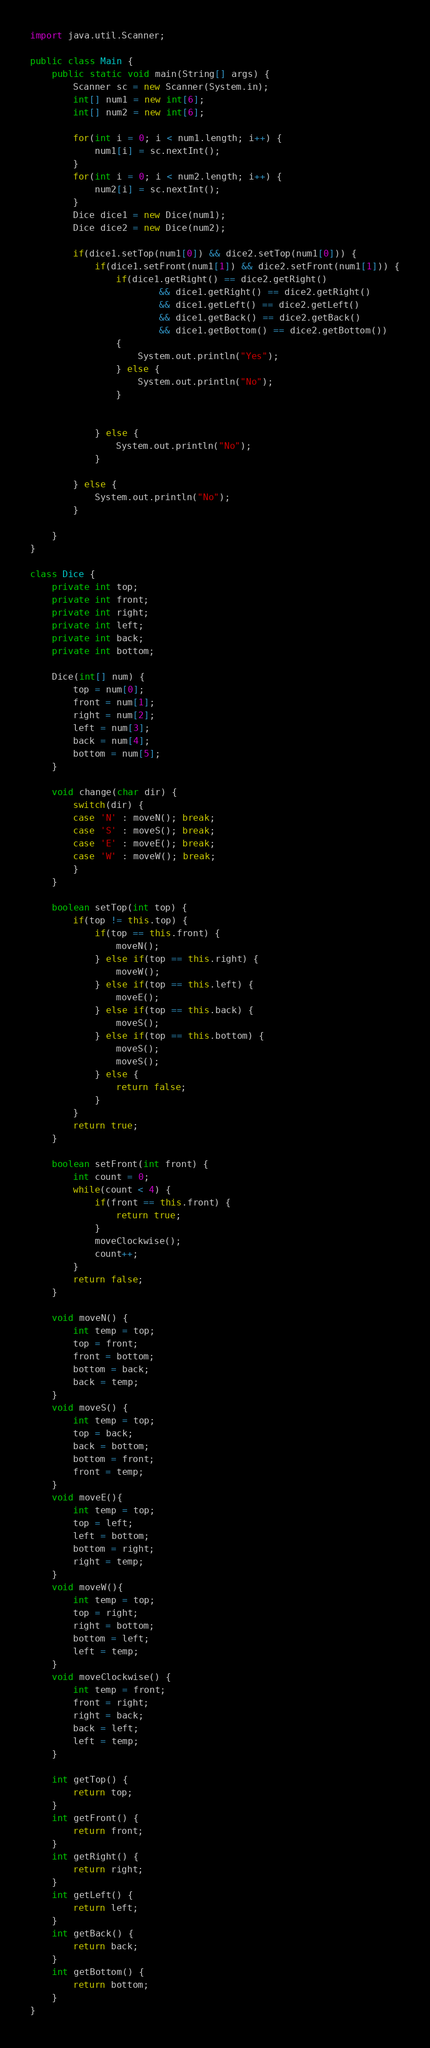Convert code to text. <code><loc_0><loc_0><loc_500><loc_500><_Java_>import java.util.Scanner;

public class Main {
    public static void main(String[] args) {
        Scanner sc = new Scanner(System.in);
        int[] num1 = new int[6];
        int[] num2 = new int[6];

        for(int i = 0; i < num1.length; i++) {
        	num1[i] = sc.nextInt();
        }
        for(int i = 0; i < num2.length; i++) {
        	num2[i] = sc.nextInt();
        }
        Dice dice1 = new Dice(num1);
        Dice dice2 = new Dice(num2);

        if(dice1.setTop(num1[0]) && dice2.setTop(num1[0])) {
        	if(dice1.setFront(num1[1]) && dice2.setFront(num1[1])) {
        		if(dice1.getRight() == dice2.getRight()
        				&& dice1.getRight() == dice2.getRight()
                		&& dice1.getLeft() == dice2.getLeft()
                        && dice1.getBack() == dice2.getBack()
                        && dice1.getBottom() == dice2.getBottom())
        		{
        			System.out.println("Yes");
        		} else {
                	System.out.println("No");
        		}


        	} else {
            	System.out.println("No");
        	}

        } else {
        	System.out.println("No");
        }

    }
}

class Dice {
	private int top;
    private int front;
    private int right;
    private int left;
    private int back;
    private int bottom;

    Dice(int[] num) {
    	top = num[0];
    	front = num[1];
    	right = num[2];
    	left = num[3];
    	back = num[4];
    	bottom = num[5];
    }

    void change(char dir) {
    	switch(dir) {
    	case 'N' : moveN(); break;
    	case 'S' : moveS(); break;
    	case 'E' : moveE(); break;
    	case 'W' : moveW(); break;
    	}
    }

    boolean setTop(int top) {
    	if(top != this.top) {
    		if(top == this.front) {
    			moveN();
    		} else if(top == this.right) {
    			moveW();
    		} else if(top == this.left) {
    			moveE();
    		} else if(top == this.back) {
    			moveS();
    		} else if(top == this.bottom) {
    			moveS();
    			moveS();
    		} else {
    			return false;
    		}
    	}
    	return true;
    }

    boolean setFront(int front) {
    	int count = 0;
    	while(count < 4) {
    		if(front == this.front) {
    			return true;
    		}
    		moveClockwise();
    		count++;
    	}
    	return false;
    }

    void moveN() {
    	int temp = top;
    	top = front;
    	front = bottom;
    	bottom = back;
    	back = temp;
    }
    void moveS() {
    	int temp = top;
    	top = back;
    	back = bottom;
    	bottom = front;
    	front = temp;
    }
    void moveE(){
        int temp = top;
        top = left;
        left = bottom;
        bottom = right;
        right = temp;
    }
    void moveW(){
        int temp = top;
        top = right;
        right = bottom;
        bottom = left;
        left = temp;
    }
    void moveClockwise() {
    	int temp = front;
    	front = right;
    	right = back;
    	back = left;
    	left = temp;
    }

    int getTop() {
    	return top;
    }
    int getFront() {
    	return front;
    }
    int getRight() {
    	return right;
    }
    int getLeft() {
    	return left;
    }
    int getBack() {
    	return back;
    }
    int getBottom() {
    	return bottom;
    }
}
</code> 